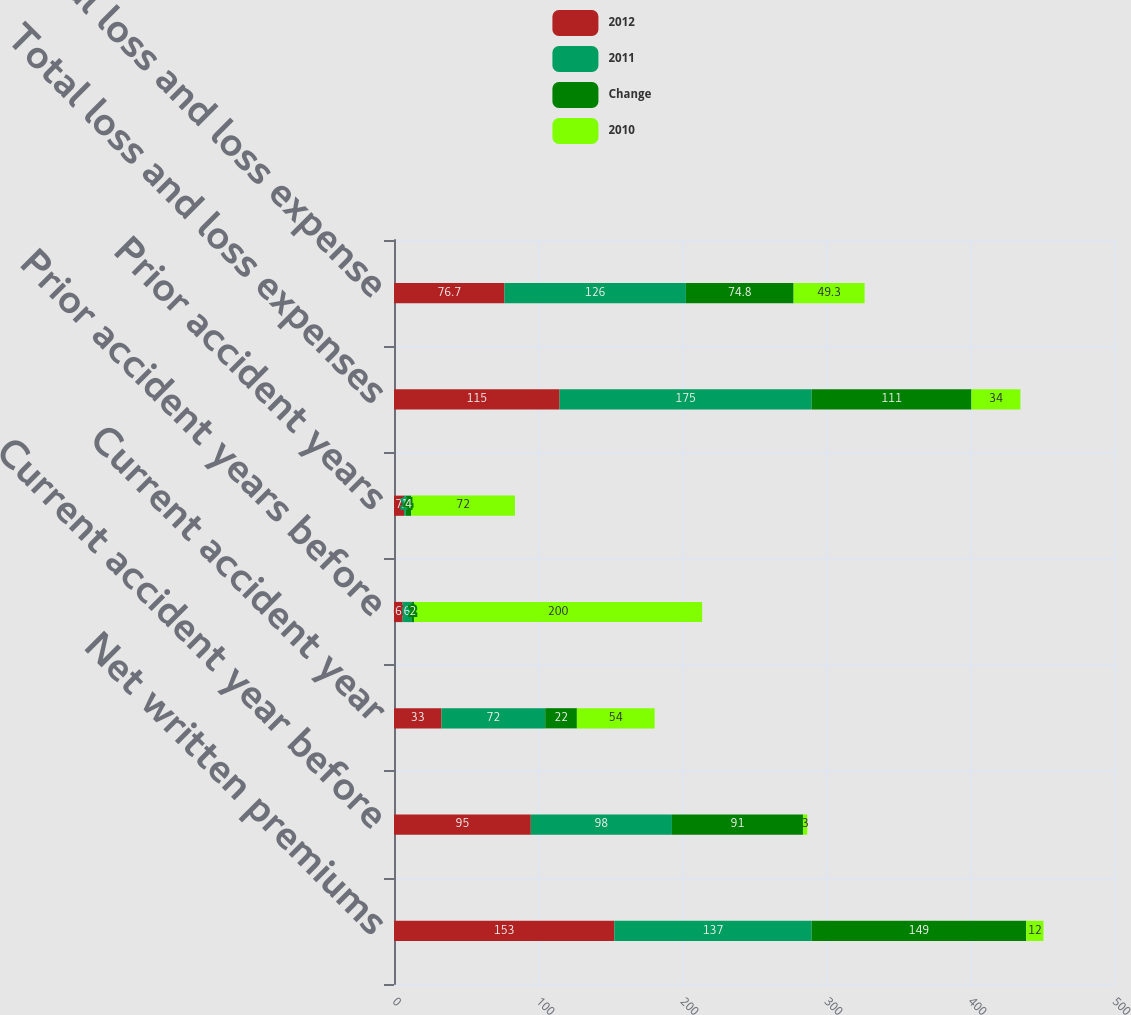Convert chart. <chart><loc_0><loc_0><loc_500><loc_500><stacked_bar_chart><ecel><fcel>Net written premiums<fcel>Current accident year before<fcel>Current accident year<fcel>Prior accident years before<fcel>Prior accident years<fcel>Total loss and loss expenses<fcel>Total loss and loss expense<nl><fcel>2012<fcel>153<fcel>95<fcel>33<fcel>6<fcel>7<fcel>115<fcel>76.7<nl><fcel>2011<fcel>137<fcel>98<fcel>72<fcel>6<fcel>1<fcel>175<fcel>126<nl><fcel>Change<fcel>149<fcel>91<fcel>22<fcel>2<fcel>4<fcel>111<fcel>74.8<nl><fcel>2010<fcel>12<fcel>3<fcel>54<fcel>200<fcel>72<fcel>34<fcel>49.3<nl></chart> 